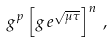<formula> <loc_0><loc_0><loc_500><loc_500>g ^ { p } \left [ g \, e ^ { \sqrt { \mu \tau } } \right ] ^ { n } \, ,</formula> 